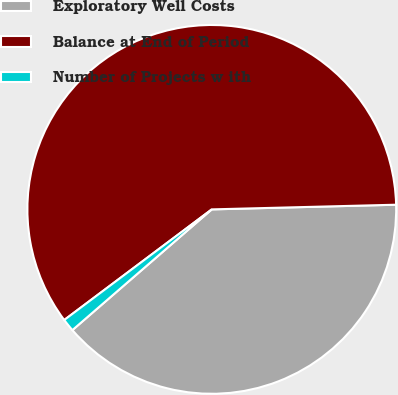Convert chart. <chart><loc_0><loc_0><loc_500><loc_500><pie_chart><fcel>Exploratory Well Costs<fcel>Balance at End of Period<fcel>Number of Projects w ith<nl><fcel>39.04%<fcel>59.83%<fcel>1.12%<nl></chart> 